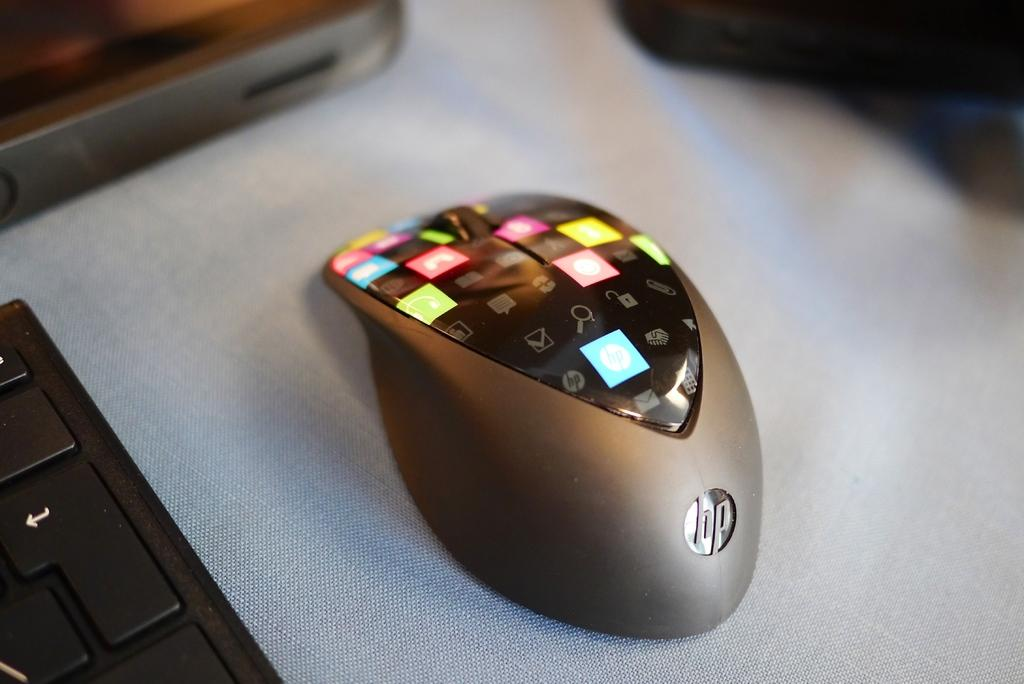<image>
Provide a brief description of the given image. an HP mouse with colorful button sits on a white cloth 